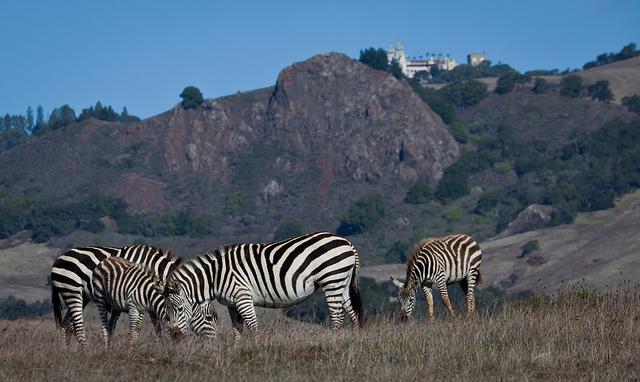How many zebras are there?
Answer briefly. 4. Where is the baby Zebra?
Keep it brief. Middle of 2. Does it appear to be windy in the image?
Keep it brief. No. Does these animals live in a zoo?
Concise answer only. No. What country has the most of these animals?
Write a very short answer. Africa. Is the zebra in captivity?
Keep it brief. No. 